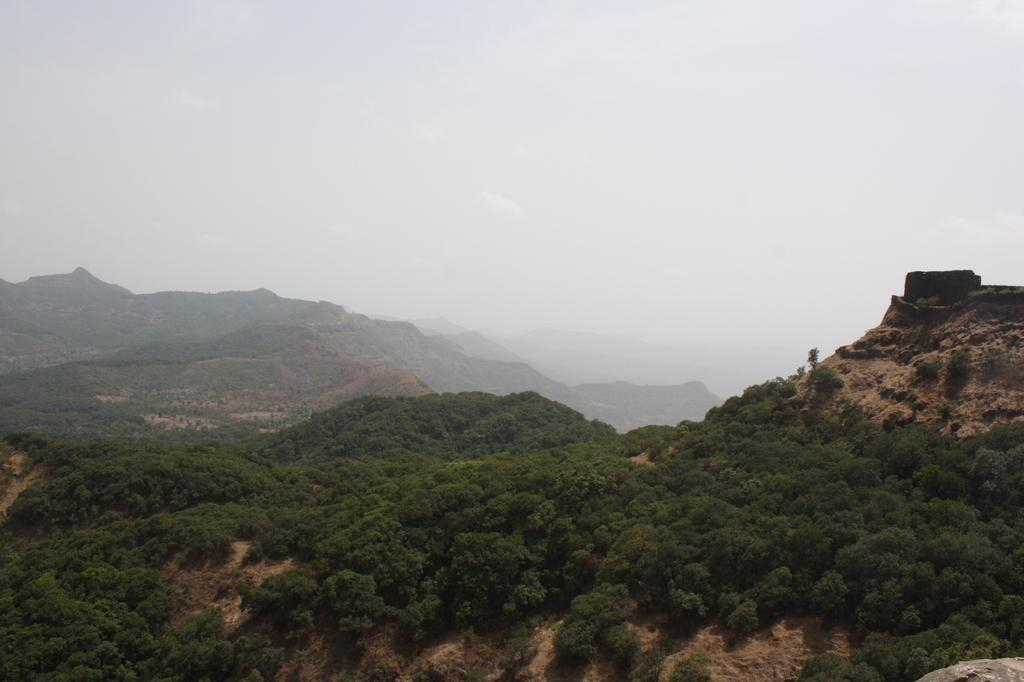What is the main subject of the image? The main subject of the image is a mountain. What can be seen on the mountain in the image? There are trees on the mountain in the image. What is visible at the top of the mountain in the image? The sky is visible at the top of the mountain in the image. What type of apparel is being worn by the trees on the mountain? Trees do not wear apparel, so this question cannot be answered. Can you see a net on the mountain in the image? There is no mention of a net in the image, so it cannot be confirmed or denied. 